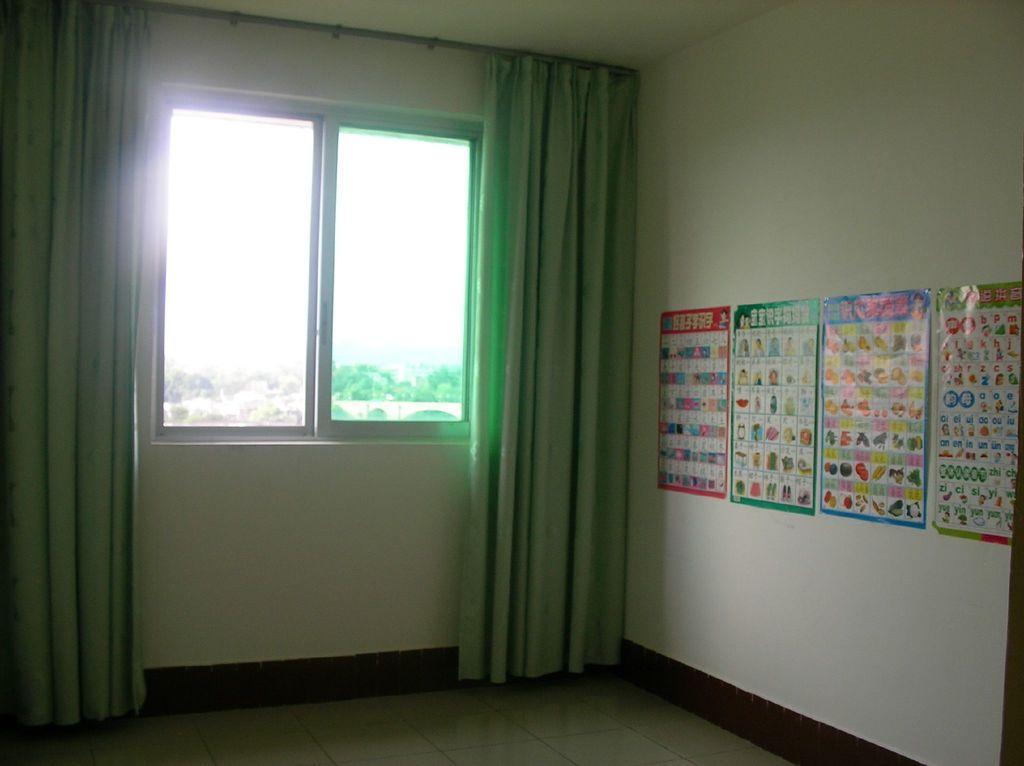In one or two sentences, can you explain what this image depicts? In the foreground of this image, there is a floor at the bottom and also we can see few posts on the wall, curtains and a window. 